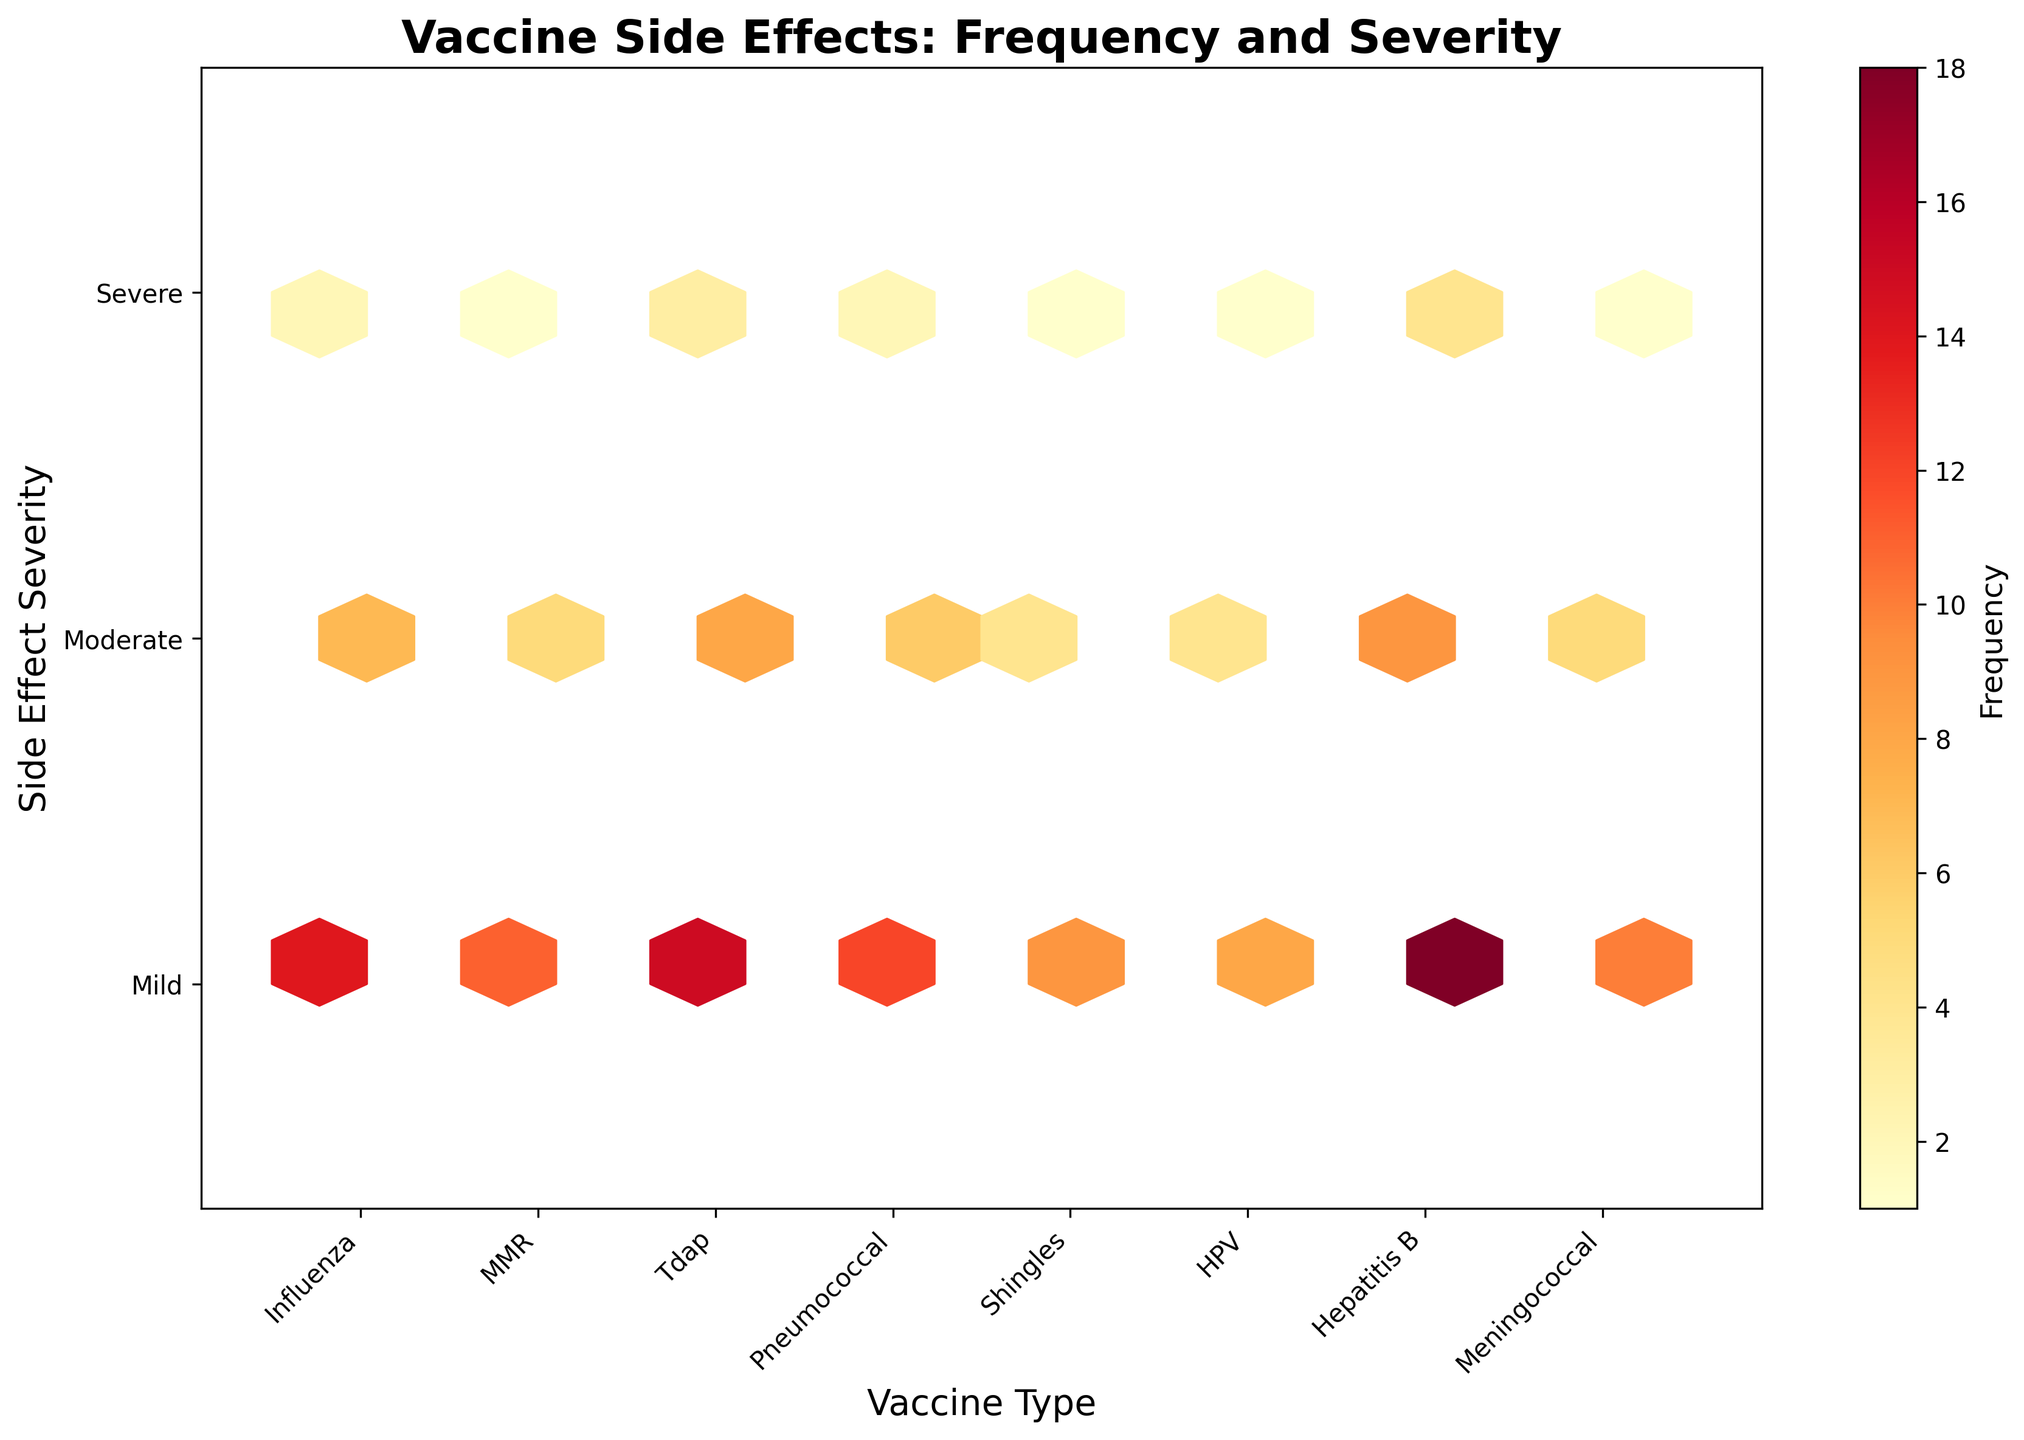What is the title of the plot? The title of the plot is given at the top of the figure in bold and larger font size.
Answer: Vaccine Side Effects: Frequency and Severity Which vaccines have the "Moderate" side effect severity the most commonly? "Moderate" side effect severity corresponds to a severity level of 2 on the y-axis. By visually examining the plot, the hexbin cells with intensity/higher frequency counts can be seen. For severity level 2, the Shingles and Influenza vaccines have more frequently occurring moderate side effects.
Answer: Shingles, Influenza How many vaccines are represented in the plot? The x-axis of the plot shows different vaccine types represented using distinct labels. By counting these labels, we can find the number of vaccines represented.
Answer: 8 Which vaccine has the highest frequency of severe side effects? "Severe" side effects correspond to a severity level of 3 on the y-axis. The hexbin with the highest intensity in the severity level 3 row indicates the highest frequency of severe side effects.
Answer: Shingles Compare the frequencies of mild side effects between the MMR and Tdap vaccines. Mild side effects correspond to a severity level of 1 on the y-axis. By looking at the hexbin frequencies in this row for both MMR and Tdap, we see 12 for MMR and 10 for Tdap.
Answer: MMR is higher Which vaccine has the most frequently occurring mild side effects? The vaccine with the hexbin containing the highest intensity (or frequency count) at severity level 1 in the y-axis can be identified.
Answer: Shingles How do the moderate side effects of HPV compare to those of Hepatitis B? Observing the hexbin intensities at severity level 2 on the y-axis for both HPV and Hepatitis B. HPV has a frequency of 7, while Hepatitis B has a frequency of 5.
Answer: HPV is higher What is the frequency range used in the color map? The color map on the right side of the plot (color bar) indicates the range of frequencies represented in the hexbin plot. By observing the color bar, we find the minimum and maximum values in the range.
Answer: 1 to 18 Are the severity levels of "Moderate" and "Severe" side effects for the Pneumococcal vaccine similar? Cross-referencing the Pneumococcal vaccine and checking hexbin counts at severity levels 2 (Moderate) and 3 (Severe), they have frequencies of 4 and 1 respectively.
Answer: No, Moderate is higher Which vaccine type shows the least frequent side effects overall? By identifying the vaccine type with the least intense hexbin colors (lowest overall frequency counts) across all severity levels; Tdap and Pneumococcal exhibit low intensities.
Answer: Tdap or Pneumococcal 